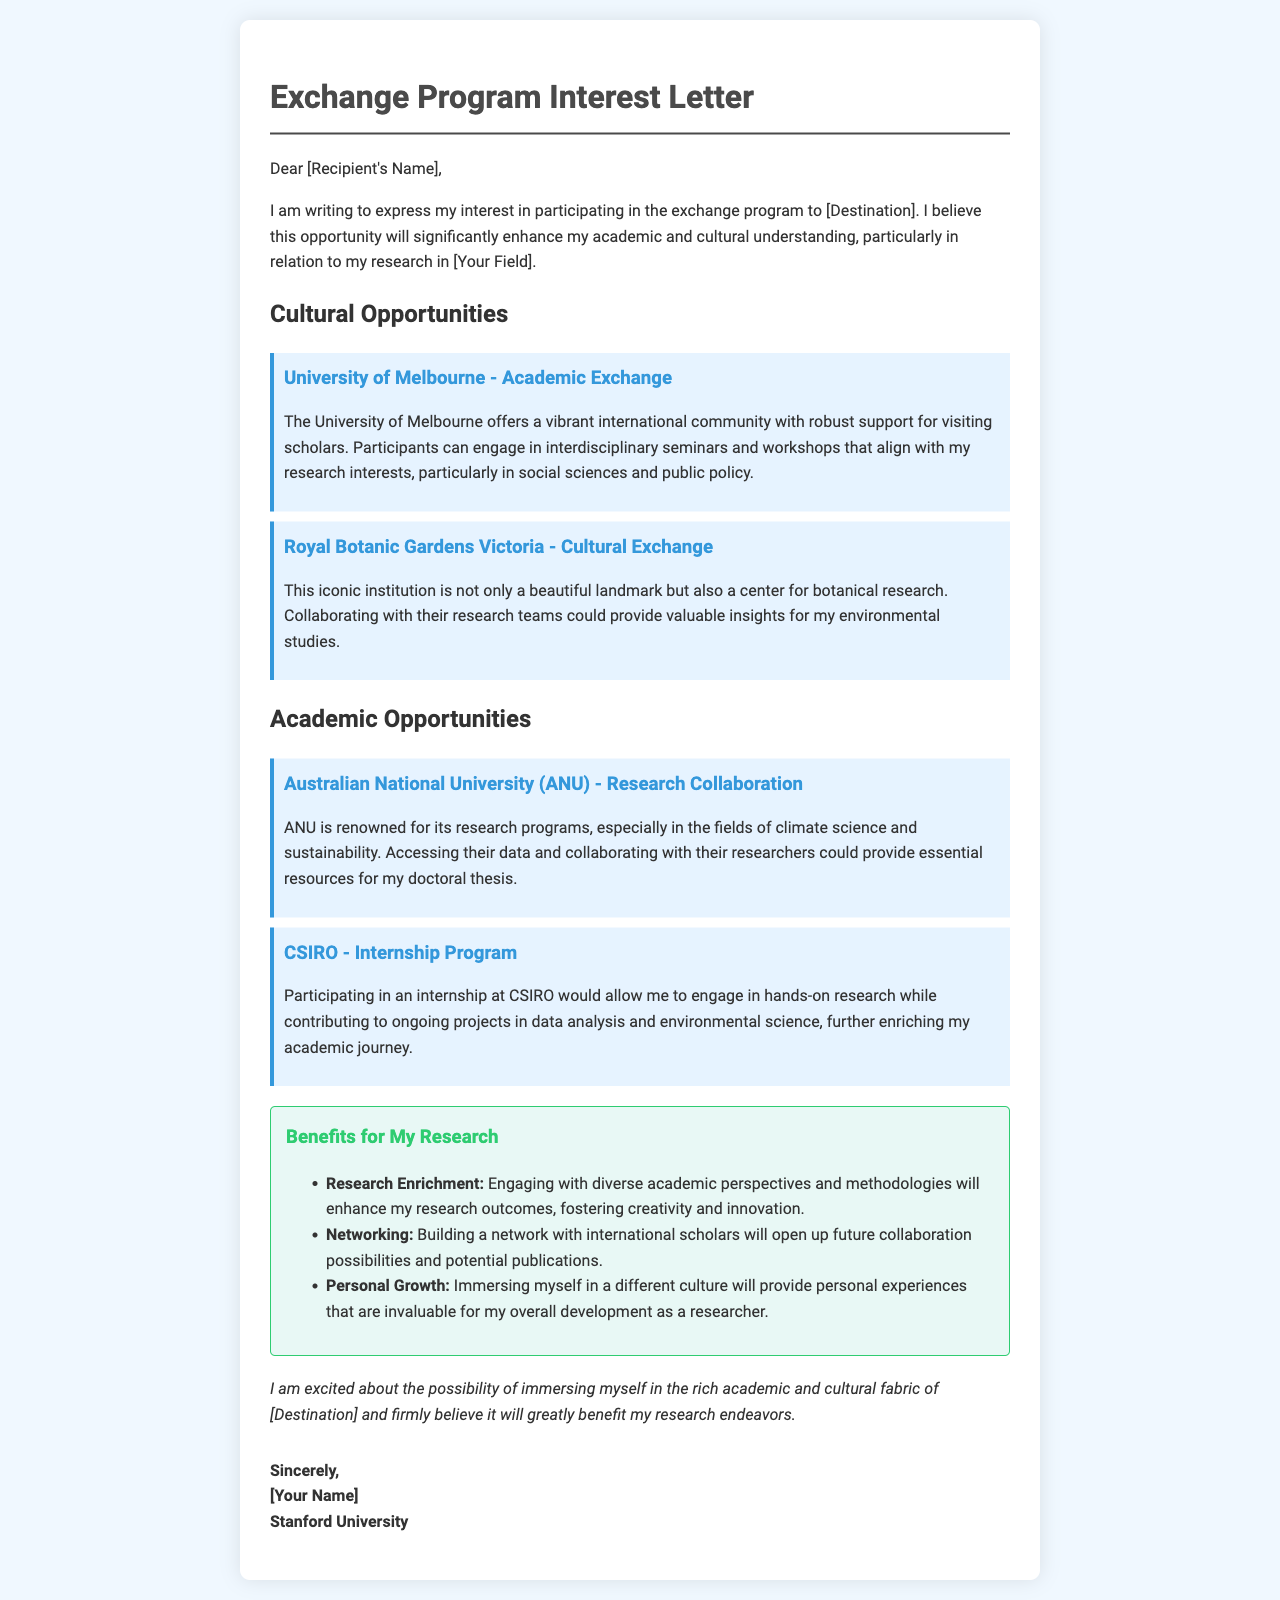what is the name of the first cultural opportunity listed? The first cultural opportunity mentioned in the document is related to the University of Melbourne.
Answer: University of Melbourne - Academic Exchange how many academic opportunities are described in the document? The document lists two academic opportunities.
Answer: 2 what type of program does CSIRO offer? CSIRO offers an internship program as a part of its academic opportunities.
Answer: Internship Program what is one benefit for research mentioned in the letter? The letter mentions several benefits for research, one of which is engaging with diverse academic perspectives.
Answer: Research Enrichment which university is known for climate science and sustainability? The Australian National University (ANU) is specifically known for its research programs in these areas.
Answer: Australian National University (ANU) what is the closing statement in the letter? The closing statement expresses excitement about the potential opportunity in the destination, focusing on its benefits.
Answer: I am excited about the possibility of immersing myself in the rich academic and cultural fabric of [Destination] and firmly believe it will greatly benefit my research endeavors what type of document is this? This document is an interest letter regarding an exchange program.
Answer: Exchange Program Interest Letter 